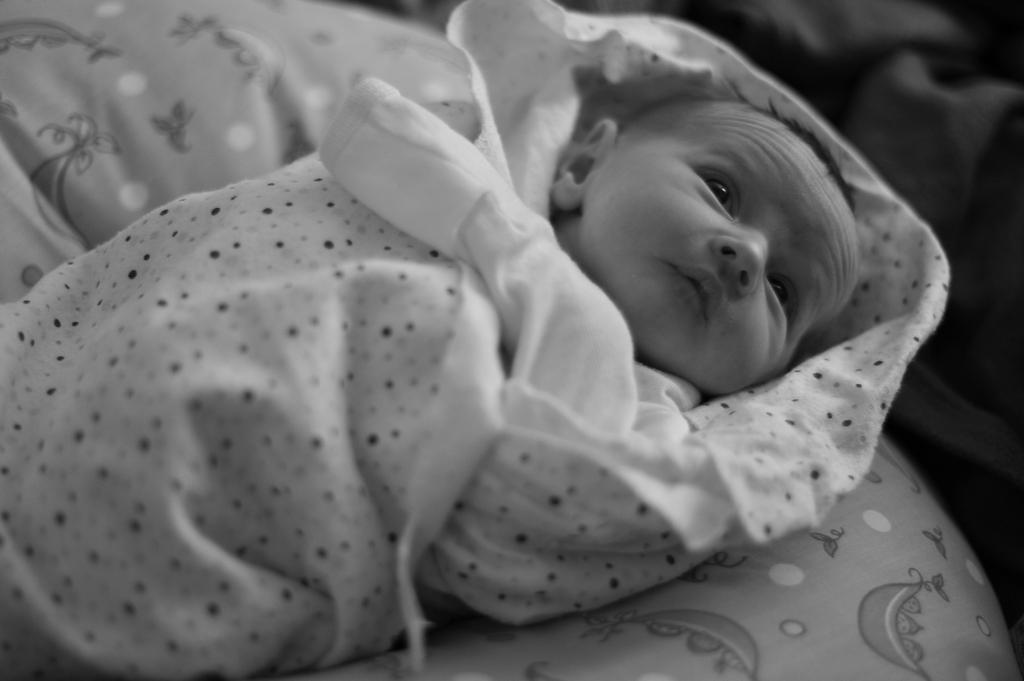What is the main subject of the image? The main subject of the image is a baby. What is the baby positioned on in the image? The baby is on a cloth in the image. What type of profit can be seen being made at the airport in the image? There is no airport or profit present in the image; it features a baby on a cloth. How does the baby twist and turn on the cloth in the image? The baby is not shown twisting or turning in the image; it is simply positioned on the cloth. 